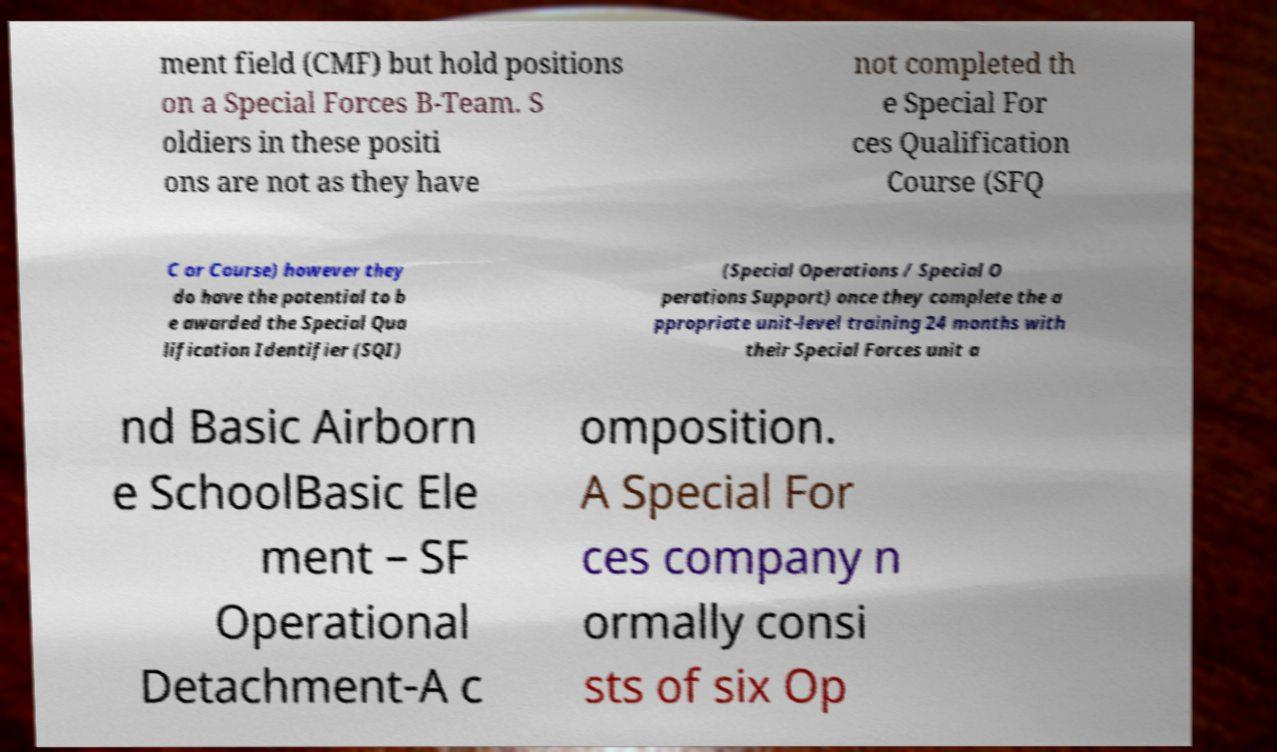What messages or text are displayed in this image? I need them in a readable, typed format. ment field (CMF) but hold positions on a Special Forces B-Team. S oldiers in these positi ons are not as they have not completed th e Special For ces Qualification Course (SFQ C or Course) however they do have the potential to b e awarded the Special Qua lification Identifier (SQI) (Special Operations / Special O perations Support) once they complete the a ppropriate unit-level training 24 months with their Special Forces unit a nd Basic Airborn e SchoolBasic Ele ment – SF Operational Detachment-A c omposition. A Special For ces company n ormally consi sts of six Op 